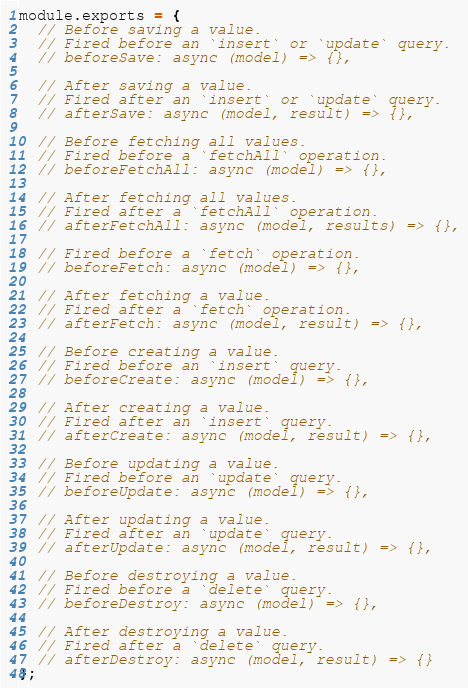Convert code to text. <code><loc_0><loc_0><loc_500><loc_500><_JavaScript_>
module.exports = {
  // Before saving a value.
  // Fired before an `insert` or `update` query.
  // beforeSave: async (model) => {},

  // After saving a value.
  // Fired after an `insert` or `update` query.
  // afterSave: async (model, result) => {},

  // Before fetching all values.
  // Fired before a `fetchAll` operation.
  // beforeFetchAll: async (model) => {},

  // After fetching all values.
  // Fired after a `fetchAll` operation.
  // afterFetchAll: async (model, results) => {},

  // Fired before a `fetch` operation.
  // beforeFetch: async (model) => {},

  // After fetching a value.
  // Fired after a `fetch` operation.
  // afterFetch: async (model, result) => {},

  // Before creating a value.
  // Fired before an `insert` query.
  // beforeCreate: async (model) => {},

  // After creating a value.
  // Fired after an `insert` query.
  // afterCreate: async (model, result) => {},

  // Before updating a value.
  // Fired before an `update` query.
  // beforeUpdate: async (model) => {},

  // After updating a value.
  // Fired after an `update` query.
  // afterUpdate: async (model, result) => {},

  // Before destroying a value.
  // Fired before a `delete` query.
  // beforeDestroy: async (model) => {},

  // After destroying a value.
  // Fired after a `delete` query.
  // afterDestroy: async (model, result) => {}
};
</code> 